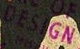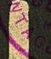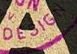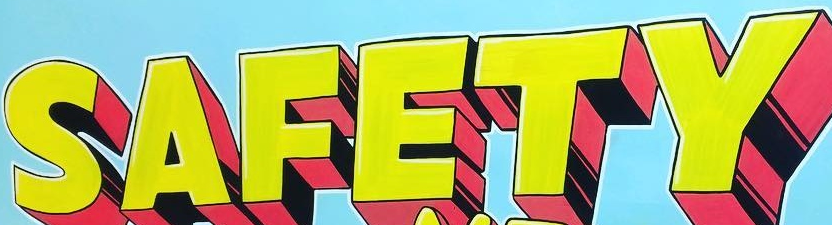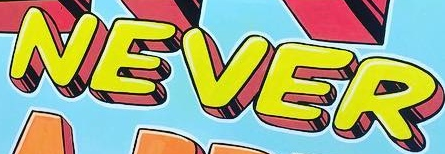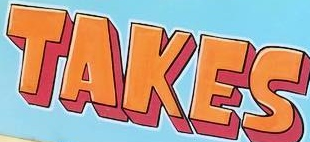Transcribe the words shown in these images in order, separated by a semicolon. DESIGN; NTAG; DESIGN; SAFETY; NEVER; TAKES 